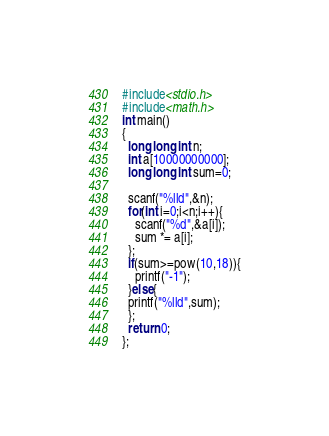<code> <loc_0><loc_0><loc_500><loc_500><_C_>#include<stdio.h>
#include<math.h>
int main()
{
  long long int n;
  int a[10000000000];
  long long int sum=0;
  
  scanf("%lld",&n);
  for(int i=0;i<n;i++){
    scanf("%d",&a[i]);
    sum *= a[i];
  };
  if(sum>=pow(10,18)){
    printf("-1");
  }else{
  printf("%lld",sum);
  };
  return 0;
};</code> 